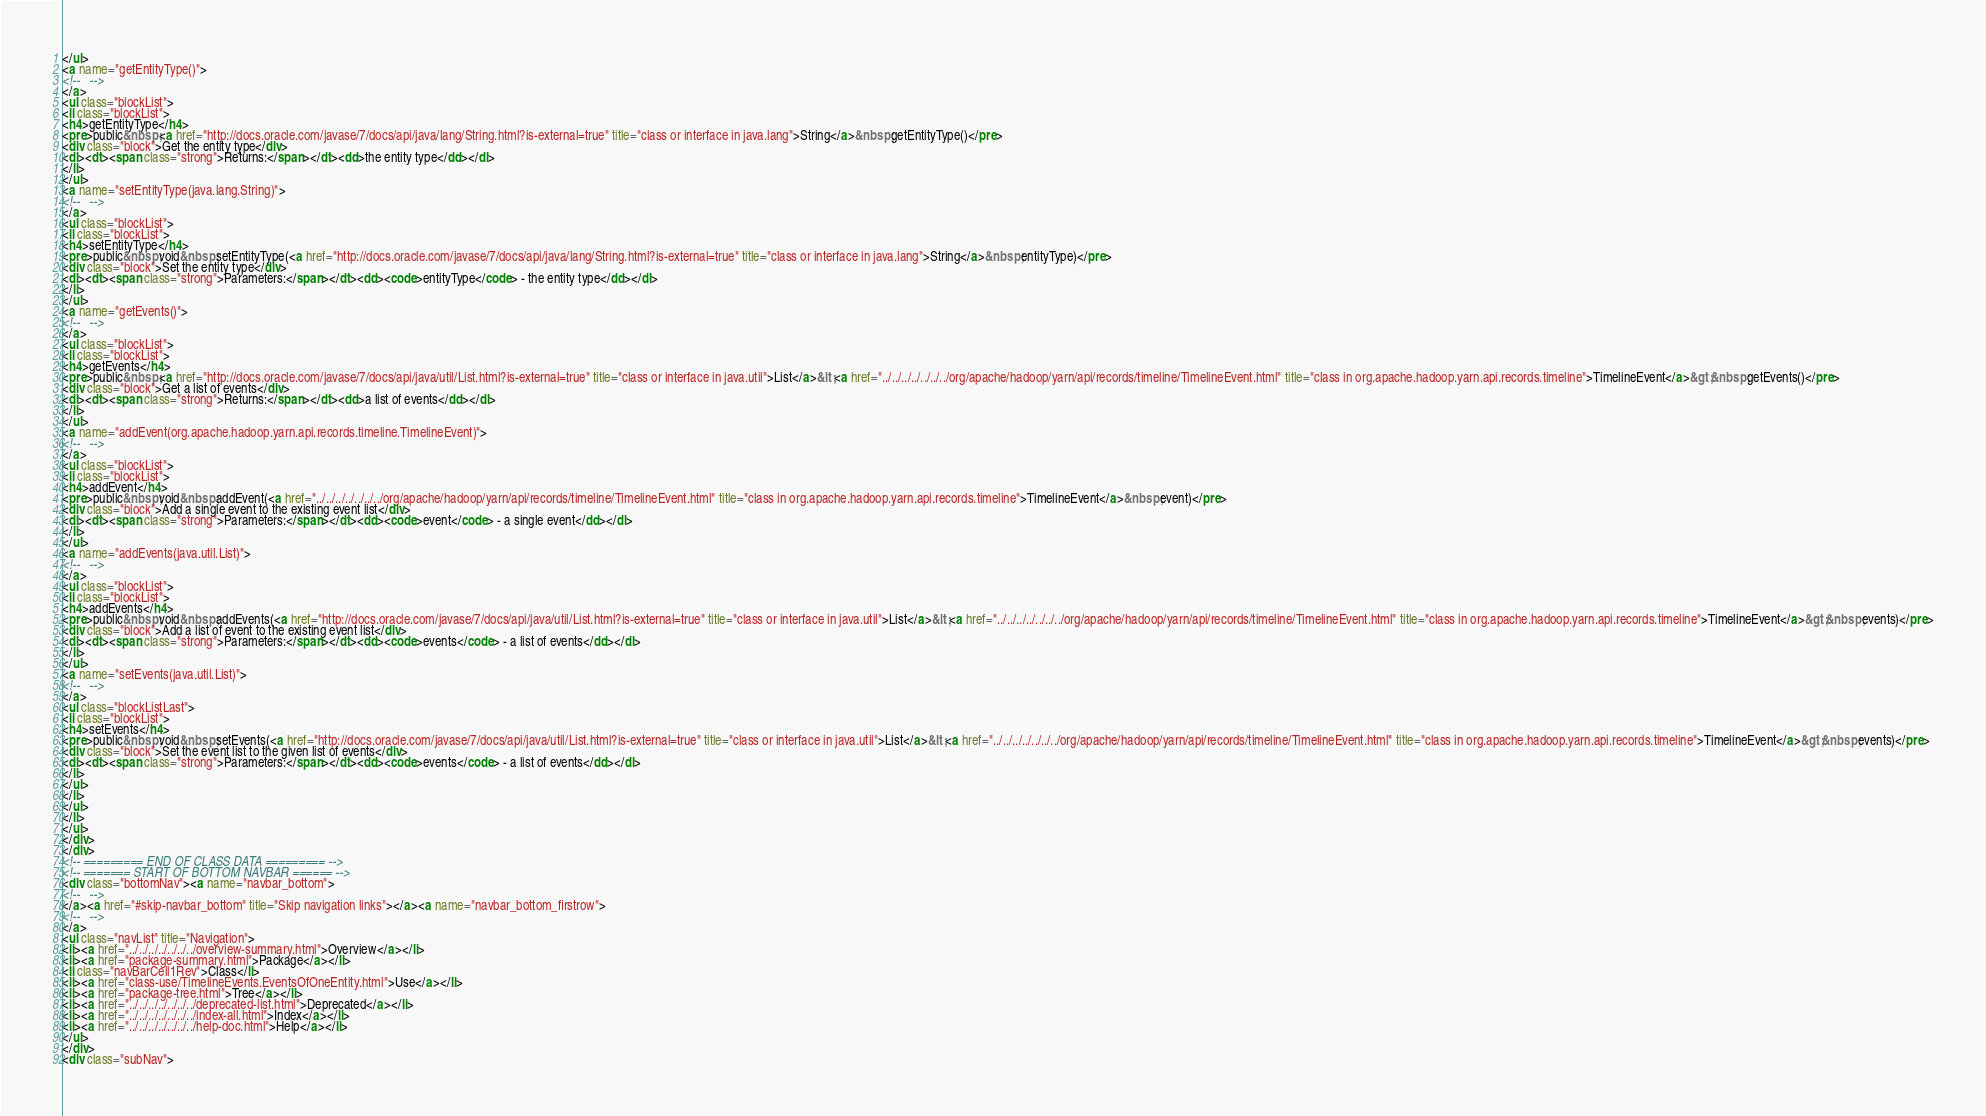<code> <loc_0><loc_0><loc_500><loc_500><_HTML_></ul>
<a name="getEntityType()">
<!--   -->
</a>
<ul class="blockList">
<li class="blockList">
<h4>getEntityType</h4>
<pre>public&nbsp;<a href="http://docs.oracle.com/javase/7/docs/api/java/lang/String.html?is-external=true" title="class or interface in java.lang">String</a>&nbsp;getEntityType()</pre>
<div class="block">Get the entity type</div>
<dl><dt><span class="strong">Returns:</span></dt><dd>the entity type</dd></dl>
</li>
</ul>
<a name="setEntityType(java.lang.String)">
<!--   -->
</a>
<ul class="blockList">
<li class="blockList">
<h4>setEntityType</h4>
<pre>public&nbsp;void&nbsp;setEntityType(<a href="http://docs.oracle.com/javase/7/docs/api/java/lang/String.html?is-external=true" title="class or interface in java.lang">String</a>&nbsp;entityType)</pre>
<div class="block">Set the entity type</div>
<dl><dt><span class="strong">Parameters:</span></dt><dd><code>entityType</code> - the entity type</dd></dl>
</li>
</ul>
<a name="getEvents()">
<!--   -->
</a>
<ul class="blockList">
<li class="blockList">
<h4>getEvents</h4>
<pre>public&nbsp;<a href="http://docs.oracle.com/javase/7/docs/api/java/util/List.html?is-external=true" title="class or interface in java.util">List</a>&lt;<a href="../../../../../../../org/apache/hadoop/yarn/api/records/timeline/TimelineEvent.html" title="class in org.apache.hadoop.yarn.api.records.timeline">TimelineEvent</a>&gt;&nbsp;getEvents()</pre>
<div class="block">Get a list of events</div>
<dl><dt><span class="strong">Returns:</span></dt><dd>a list of events</dd></dl>
</li>
</ul>
<a name="addEvent(org.apache.hadoop.yarn.api.records.timeline.TimelineEvent)">
<!--   -->
</a>
<ul class="blockList">
<li class="blockList">
<h4>addEvent</h4>
<pre>public&nbsp;void&nbsp;addEvent(<a href="../../../../../../../org/apache/hadoop/yarn/api/records/timeline/TimelineEvent.html" title="class in org.apache.hadoop.yarn.api.records.timeline">TimelineEvent</a>&nbsp;event)</pre>
<div class="block">Add a single event to the existing event list</div>
<dl><dt><span class="strong">Parameters:</span></dt><dd><code>event</code> - a single event</dd></dl>
</li>
</ul>
<a name="addEvents(java.util.List)">
<!--   -->
</a>
<ul class="blockList">
<li class="blockList">
<h4>addEvents</h4>
<pre>public&nbsp;void&nbsp;addEvents(<a href="http://docs.oracle.com/javase/7/docs/api/java/util/List.html?is-external=true" title="class or interface in java.util">List</a>&lt;<a href="../../../../../../../org/apache/hadoop/yarn/api/records/timeline/TimelineEvent.html" title="class in org.apache.hadoop.yarn.api.records.timeline">TimelineEvent</a>&gt;&nbsp;events)</pre>
<div class="block">Add a list of event to the existing event list</div>
<dl><dt><span class="strong">Parameters:</span></dt><dd><code>events</code> - a list of events</dd></dl>
</li>
</ul>
<a name="setEvents(java.util.List)">
<!--   -->
</a>
<ul class="blockListLast">
<li class="blockList">
<h4>setEvents</h4>
<pre>public&nbsp;void&nbsp;setEvents(<a href="http://docs.oracle.com/javase/7/docs/api/java/util/List.html?is-external=true" title="class or interface in java.util">List</a>&lt;<a href="../../../../../../../org/apache/hadoop/yarn/api/records/timeline/TimelineEvent.html" title="class in org.apache.hadoop.yarn.api.records.timeline">TimelineEvent</a>&gt;&nbsp;events)</pre>
<div class="block">Set the event list to the given list of events</div>
<dl><dt><span class="strong">Parameters:</span></dt><dd><code>events</code> - a list of events</dd></dl>
</li>
</ul>
</li>
</ul>
</li>
</ul>
</div>
</div>
<!-- ========= END OF CLASS DATA ========= -->
<!-- ======= START OF BOTTOM NAVBAR ====== -->
<div class="bottomNav"><a name="navbar_bottom">
<!--   -->
</a><a href="#skip-navbar_bottom" title="Skip navigation links"></a><a name="navbar_bottom_firstrow">
<!--   -->
</a>
<ul class="navList" title="Navigation">
<li><a href="../../../../../../../overview-summary.html">Overview</a></li>
<li><a href="package-summary.html">Package</a></li>
<li class="navBarCell1Rev">Class</li>
<li><a href="class-use/TimelineEvents.EventsOfOneEntity.html">Use</a></li>
<li><a href="package-tree.html">Tree</a></li>
<li><a href="../../../../../../../deprecated-list.html">Deprecated</a></li>
<li><a href="../../../../../../../index-all.html">Index</a></li>
<li><a href="../../../../../../../help-doc.html">Help</a></li>
</ul>
</div>
<div class="subNav"></code> 